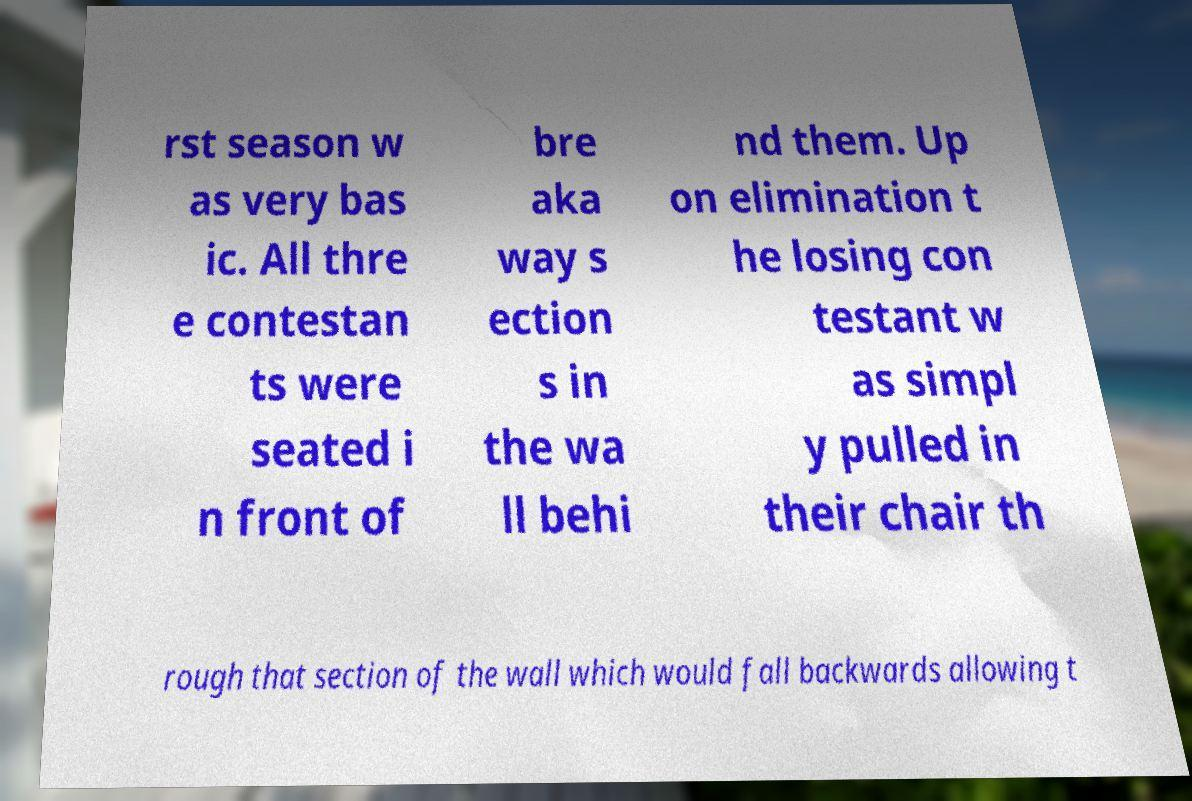I need the written content from this picture converted into text. Can you do that? rst season w as very bas ic. All thre e contestan ts were seated i n front of bre aka way s ection s in the wa ll behi nd them. Up on elimination t he losing con testant w as simpl y pulled in their chair th rough that section of the wall which would fall backwards allowing t 